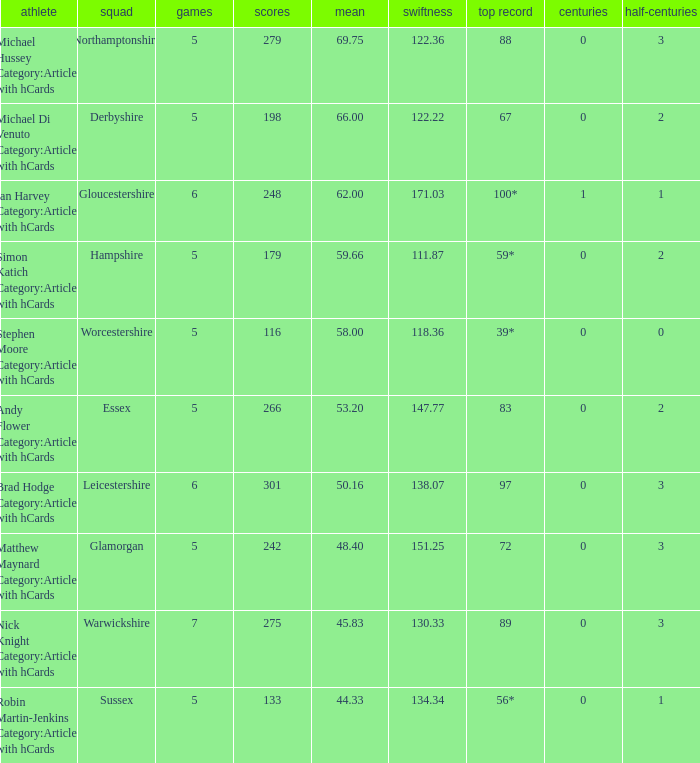If the team is Worcestershire and the Matched had were 5, what is the highest score? 39*. 